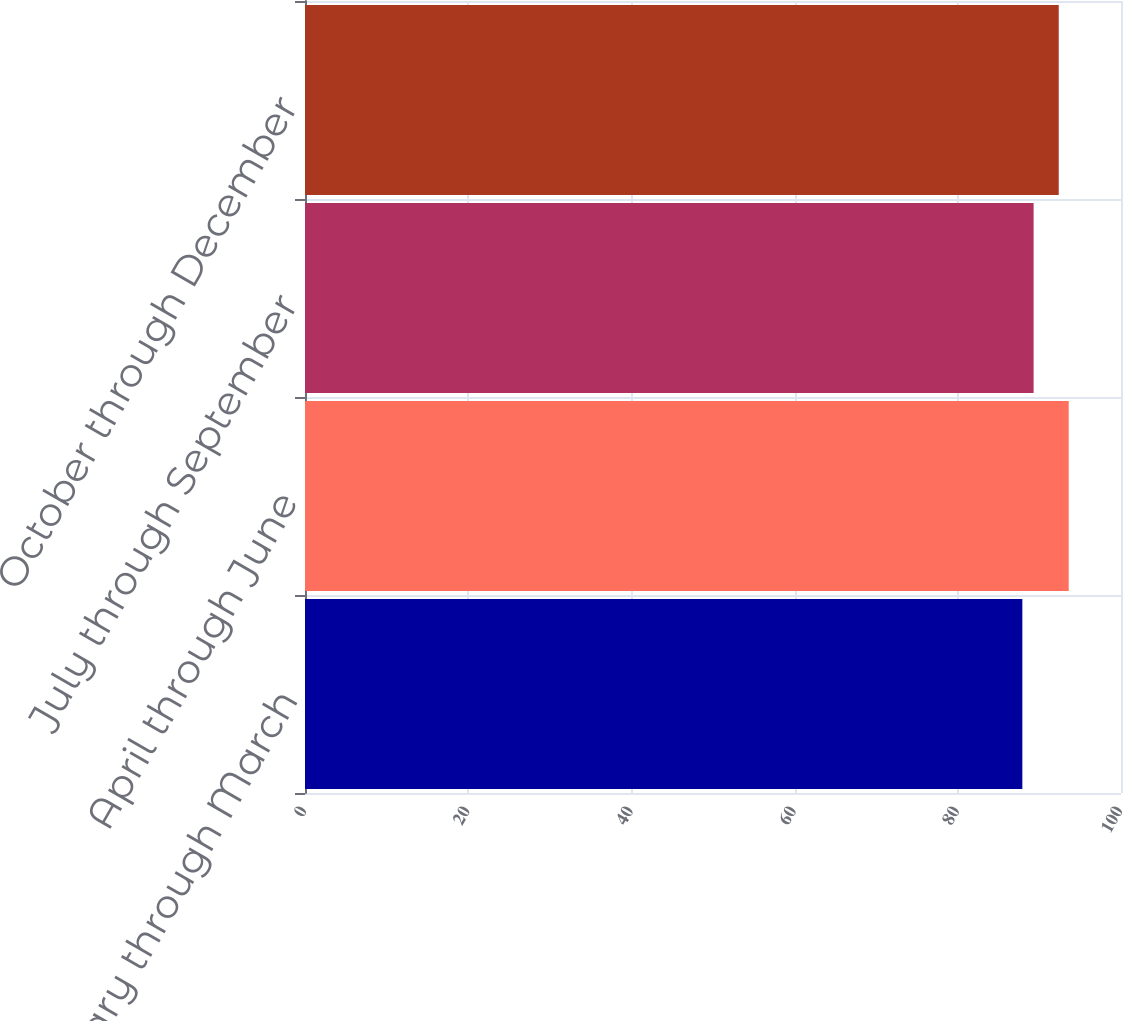<chart> <loc_0><loc_0><loc_500><loc_500><bar_chart><fcel>January through March<fcel>April through June<fcel>July through September<fcel>October through December<nl><fcel>87.91<fcel>93.59<fcel>89.29<fcel>92.37<nl></chart> 